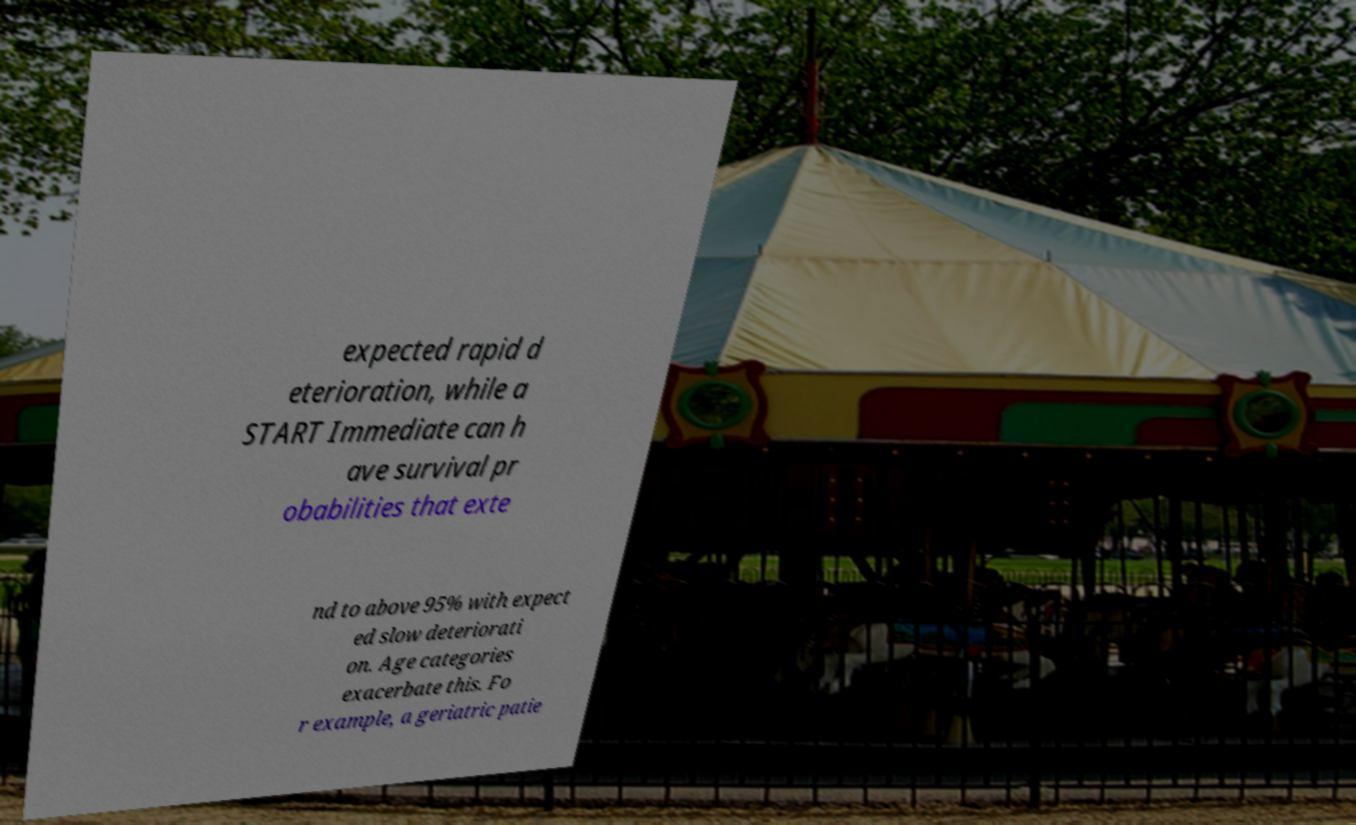For documentation purposes, I need the text within this image transcribed. Could you provide that? expected rapid d eterioration, while a START Immediate can h ave survival pr obabilities that exte nd to above 95% with expect ed slow deteriorati on. Age categories exacerbate this. Fo r example, a geriatric patie 